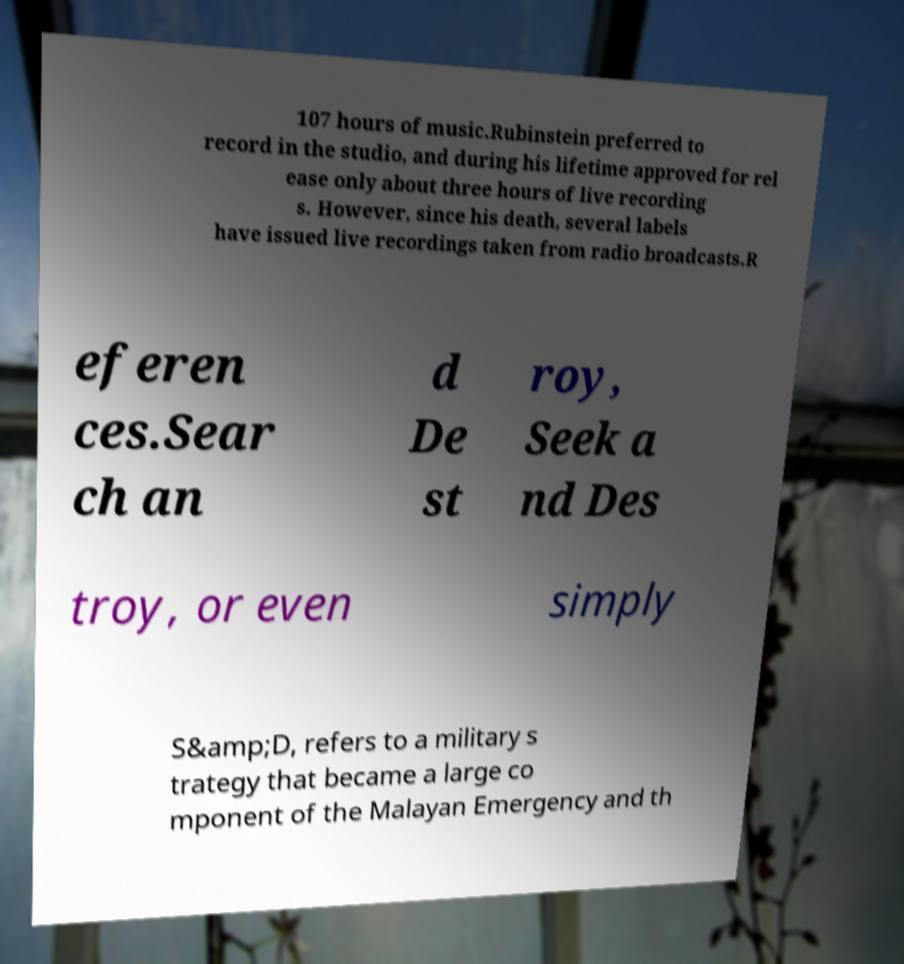For documentation purposes, I need the text within this image transcribed. Could you provide that? 107 hours of music.Rubinstein preferred to record in the studio, and during his lifetime approved for rel ease only about three hours of live recording s. However, since his death, several labels have issued live recordings taken from radio broadcasts.R eferen ces.Sear ch an d De st roy, Seek a nd Des troy, or even simply S&amp;D, refers to a military s trategy that became a large co mponent of the Malayan Emergency and th 